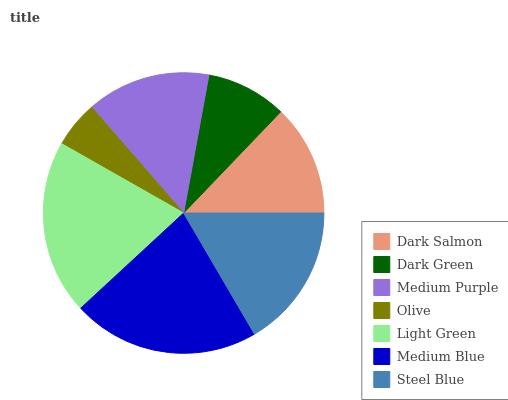Is Olive the minimum?
Answer yes or no. Yes. Is Medium Blue the maximum?
Answer yes or no. Yes. Is Dark Green the minimum?
Answer yes or no. No. Is Dark Green the maximum?
Answer yes or no. No. Is Dark Salmon greater than Dark Green?
Answer yes or no. Yes. Is Dark Green less than Dark Salmon?
Answer yes or no. Yes. Is Dark Green greater than Dark Salmon?
Answer yes or no. No. Is Dark Salmon less than Dark Green?
Answer yes or no. No. Is Medium Purple the high median?
Answer yes or no. Yes. Is Medium Purple the low median?
Answer yes or no. Yes. Is Dark Salmon the high median?
Answer yes or no. No. Is Steel Blue the low median?
Answer yes or no. No. 